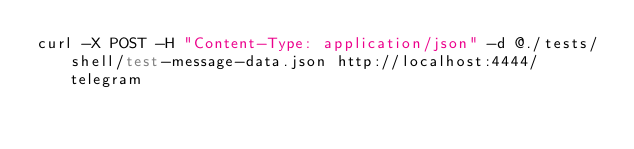<code> <loc_0><loc_0><loc_500><loc_500><_Bash_>curl -X POST -H "Content-Type: application/json" -d @./tests/shell/test-message-data.json http://localhost:4444/telegram
</code> 